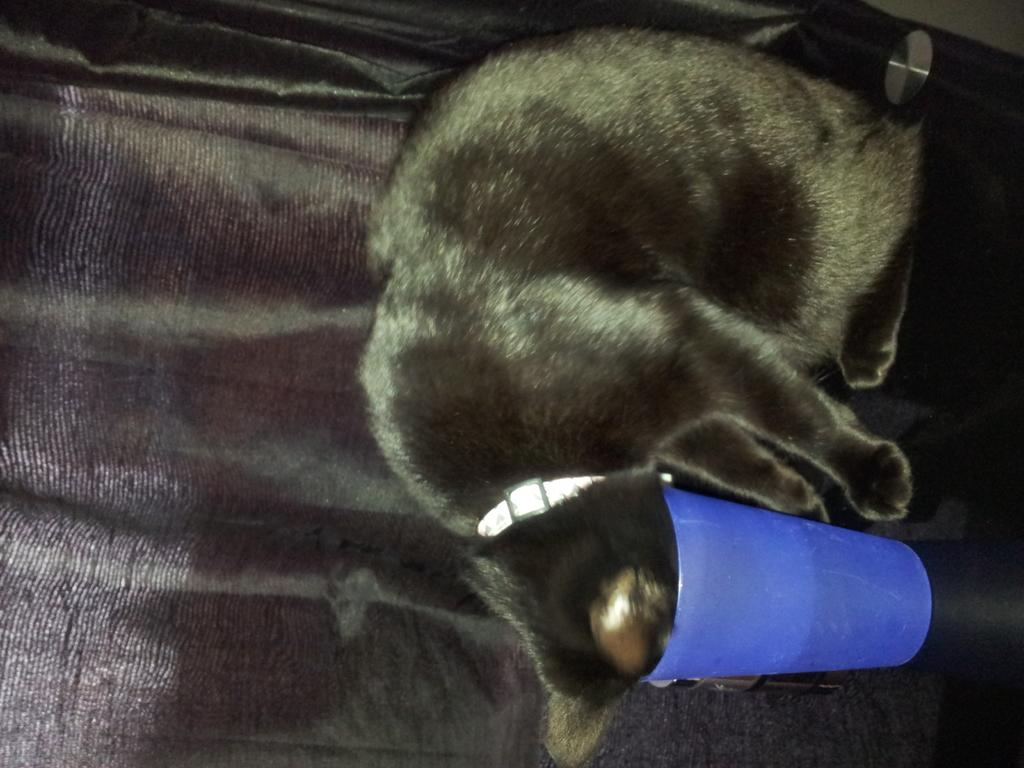What type of animal is present in the image? There is an animal in the image, but its specific type cannot be determined from the provided facts. What material is present in the image? There is glass in the image. What else can be seen in the image besides the animal and glass? There is an object in the image. What color is the background of the image? The background of the image is black. What type of invention can be seen in the image? There is no invention present in the image; it features an animal, glass, and an object. What type of shade is covering the animal in the image? There is no shade covering the animal in the image; the animal is visible. 